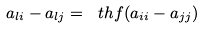Convert formula to latex. <formula><loc_0><loc_0><loc_500><loc_500>a _ { l i } - a _ { l j } = \ t h f ( a _ { i i } - a _ { j j } )</formula> 